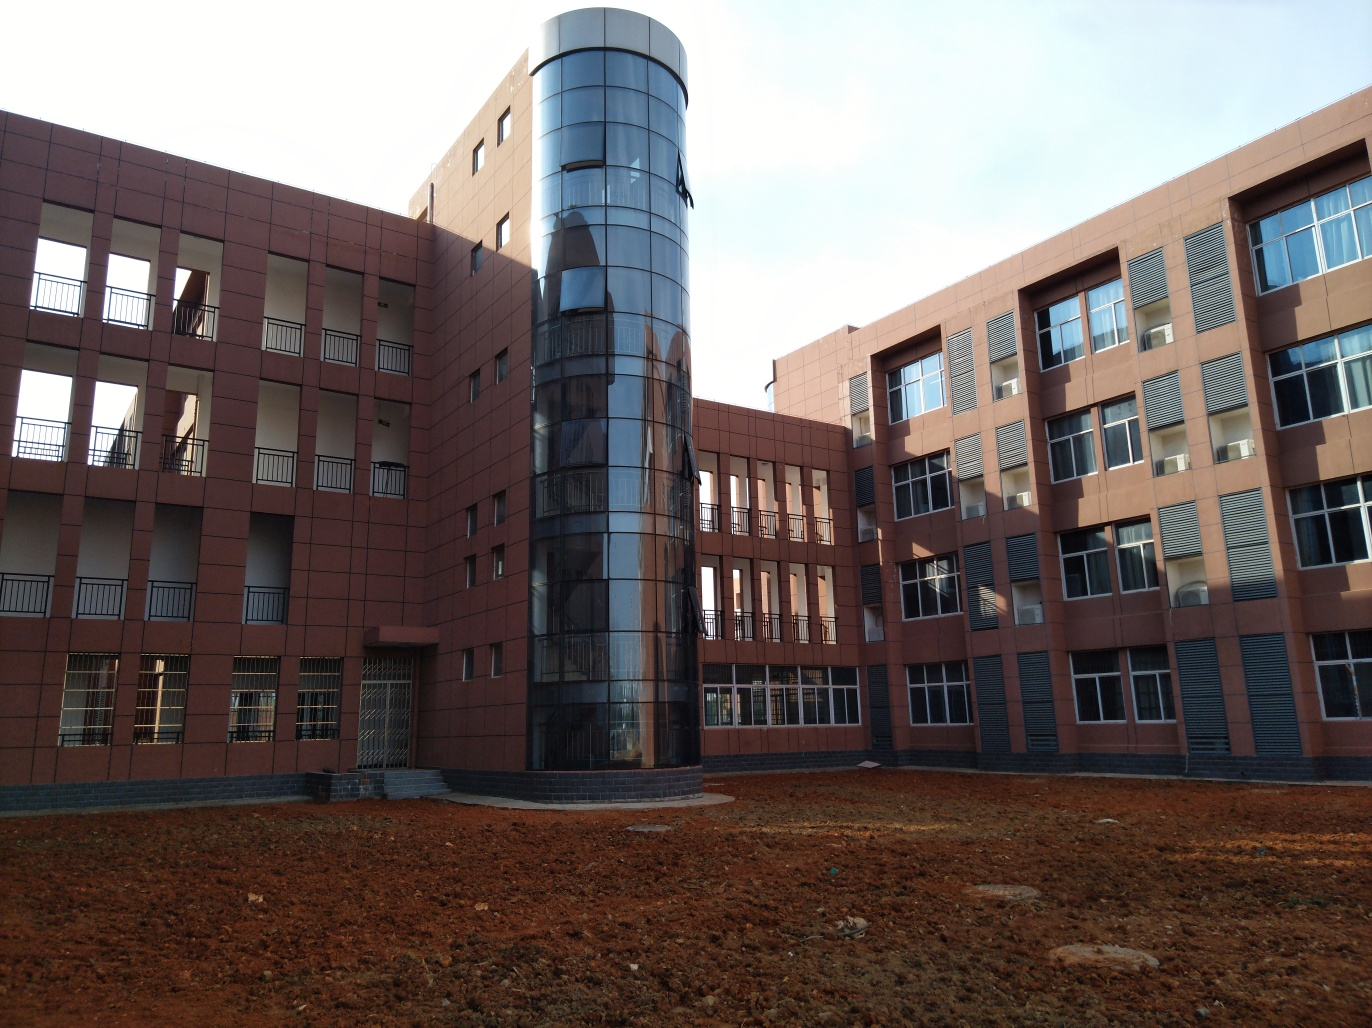Is this a new construction area? The unlandscaped ground and absence of established vegetation suggest that this could be a new construction area. It might be in the process of being developed or could have recently been completed, awaiting further landscaping and infrastructure work. 